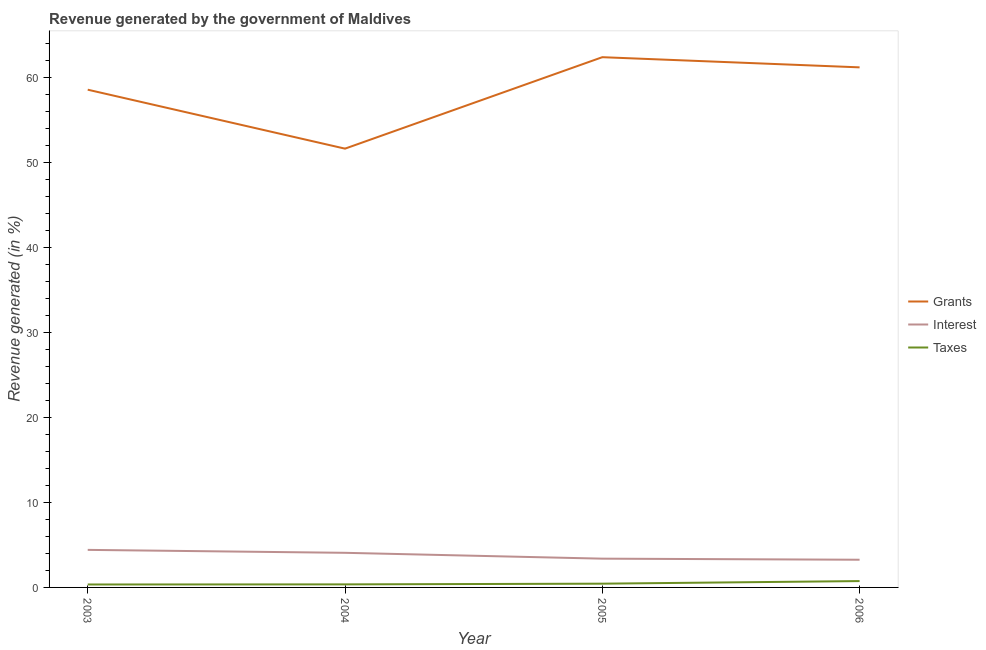Is the number of lines equal to the number of legend labels?
Provide a succinct answer. Yes. What is the percentage of revenue generated by interest in 2003?
Make the answer very short. 4.42. Across all years, what is the maximum percentage of revenue generated by interest?
Make the answer very short. 4.42. Across all years, what is the minimum percentage of revenue generated by grants?
Your response must be concise. 51.61. In which year was the percentage of revenue generated by grants maximum?
Give a very brief answer. 2005. In which year was the percentage of revenue generated by interest minimum?
Give a very brief answer. 2006. What is the total percentage of revenue generated by interest in the graph?
Provide a succinct answer. 15.13. What is the difference between the percentage of revenue generated by grants in 2003 and that in 2005?
Provide a short and direct response. -3.82. What is the difference between the percentage of revenue generated by grants in 2005 and the percentage of revenue generated by interest in 2003?
Offer a terse response. 57.95. What is the average percentage of revenue generated by grants per year?
Your response must be concise. 58.42. In the year 2003, what is the difference between the percentage of revenue generated by interest and percentage of revenue generated by taxes?
Give a very brief answer. 4.07. What is the ratio of the percentage of revenue generated by grants in 2004 to that in 2006?
Your answer should be compact. 0.84. What is the difference between the highest and the second highest percentage of revenue generated by interest?
Offer a very short reply. 0.35. What is the difference between the highest and the lowest percentage of revenue generated by grants?
Keep it short and to the point. 10.76. In how many years, is the percentage of revenue generated by interest greater than the average percentage of revenue generated by interest taken over all years?
Ensure brevity in your answer.  2. Is the sum of the percentage of revenue generated by interest in 2004 and 2005 greater than the maximum percentage of revenue generated by taxes across all years?
Offer a very short reply. Yes. Does the percentage of revenue generated by grants monotonically increase over the years?
Your answer should be very brief. No. Is the percentage of revenue generated by taxes strictly greater than the percentage of revenue generated by grants over the years?
Offer a very short reply. No. How many lines are there?
Give a very brief answer. 3. How many years are there in the graph?
Offer a very short reply. 4. What is the difference between two consecutive major ticks on the Y-axis?
Give a very brief answer. 10. Where does the legend appear in the graph?
Make the answer very short. Center right. How many legend labels are there?
Keep it short and to the point. 3. How are the legend labels stacked?
Your answer should be very brief. Vertical. What is the title of the graph?
Keep it short and to the point. Revenue generated by the government of Maldives. Does "Slovak Republic" appear as one of the legend labels in the graph?
Your response must be concise. No. What is the label or title of the X-axis?
Ensure brevity in your answer.  Year. What is the label or title of the Y-axis?
Your answer should be compact. Revenue generated (in %). What is the Revenue generated (in %) in Grants in 2003?
Your answer should be very brief. 58.54. What is the Revenue generated (in %) in Interest in 2003?
Keep it short and to the point. 4.42. What is the Revenue generated (in %) in Taxes in 2003?
Your answer should be compact. 0.35. What is the Revenue generated (in %) of Grants in 2004?
Provide a short and direct response. 51.61. What is the Revenue generated (in %) of Interest in 2004?
Provide a succinct answer. 4.07. What is the Revenue generated (in %) in Taxes in 2004?
Offer a very short reply. 0.36. What is the Revenue generated (in %) in Grants in 2005?
Your answer should be compact. 62.37. What is the Revenue generated (in %) in Interest in 2005?
Provide a short and direct response. 3.38. What is the Revenue generated (in %) of Taxes in 2005?
Your response must be concise. 0.44. What is the Revenue generated (in %) of Grants in 2006?
Ensure brevity in your answer.  61.17. What is the Revenue generated (in %) of Interest in 2006?
Your answer should be very brief. 3.26. What is the Revenue generated (in %) of Taxes in 2006?
Make the answer very short. 0.75. Across all years, what is the maximum Revenue generated (in %) in Grants?
Provide a succinct answer. 62.37. Across all years, what is the maximum Revenue generated (in %) of Interest?
Give a very brief answer. 4.42. Across all years, what is the maximum Revenue generated (in %) in Taxes?
Your answer should be very brief. 0.75. Across all years, what is the minimum Revenue generated (in %) in Grants?
Your answer should be compact. 51.61. Across all years, what is the minimum Revenue generated (in %) of Interest?
Ensure brevity in your answer.  3.26. Across all years, what is the minimum Revenue generated (in %) in Taxes?
Provide a succinct answer. 0.35. What is the total Revenue generated (in %) in Grants in the graph?
Keep it short and to the point. 233.69. What is the total Revenue generated (in %) of Interest in the graph?
Offer a terse response. 15.13. What is the total Revenue generated (in %) in Taxes in the graph?
Ensure brevity in your answer.  1.89. What is the difference between the Revenue generated (in %) in Grants in 2003 and that in 2004?
Offer a terse response. 6.93. What is the difference between the Revenue generated (in %) of Interest in 2003 and that in 2004?
Provide a short and direct response. 0.35. What is the difference between the Revenue generated (in %) in Taxes in 2003 and that in 2004?
Make the answer very short. -0.01. What is the difference between the Revenue generated (in %) of Grants in 2003 and that in 2005?
Your answer should be compact. -3.82. What is the difference between the Revenue generated (in %) in Interest in 2003 and that in 2005?
Your answer should be very brief. 1.03. What is the difference between the Revenue generated (in %) of Taxes in 2003 and that in 2005?
Provide a succinct answer. -0.09. What is the difference between the Revenue generated (in %) of Grants in 2003 and that in 2006?
Offer a terse response. -2.63. What is the difference between the Revenue generated (in %) of Interest in 2003 and that in 2006?
Offer a very short reply. 1.16. What is the difference between the Revenue generated (in %) in Taxes in 2003 and that in 2006?
Offer a very short reply. -0.4. What is the difference between the Revenue generated (in %) of Grants in 2004 and that in 2005?
Keep it short and to the point. -10.76. What is the difference between the Revenue generated (in %) in Interest in 2004 and that in 2005?
Give a very brief answer. 0.69. What is the difference between the Revenue generated (in %) of Taxes in 2004 and that in 2005?
Ensure brevity in your answer.  -0.08. What is the difference between the Revenue generated (in %) in Grants in 2004 and that in 2006?
Give a very brief answer. -9.56. What is the difference between the Revenue generated (in %) of Interest in 2004 and that in 2006?
Make the answer very short. 0.82. What is the difference between the Revenue generated (in %) of Taxes in 2004 and that in 2006?
Your answer should be very brief. -0.39. What is the difference between the Revenue generated (in %) in Grants in 2005 and that in 2006?
Your response must be concise. 1.2. What is the difference between the Revenue generated (in %) in Interest in 2005 and that in 2006?
Provide a succinct answer. 0.13. What is the difference between the Revenue generated (in %) of Taxes in 2005 and that in 2006?
Your response must be concise. -0.31. What is the difference between the Revenue generated (in %) of Grants in 2003 and the Revenue generated (in %) of Interest in 2004?
Give a very brief answer. 54.47. What is the difference between the Revenue generated (in %) in Grants in 2003 and the Revenue generated (in %) in Taxes in 2004?
Provide a short and direct response. 58.19. What is the difference between the Revenue generated (in %) in Interest in 2003 and the Revenue generated (in %) in Taxes in 2004?
Your response must be concise. 4.06. What is the difference between the Revenue generated (in %) in Grants in 2003 and the Revenue generated (in %) in Interest in 2005?
Make the answer very short. 55.16. What is the difference between the Revenue generated (in %) of Grants in 2003 and the Revenue generated (in %) of Taxes in 2005?
Offer a very short reply. 58.1. What is the difference between the Revenue generated (in %) of Interest in 2003 and the Revenue generated (in %) of Taxes in 2005?
Offer a very short reply. 3.98. What is the difference between the Revenue generated (in %) in Grants in 2003 and the Revenue generated (in %) in Interest in 2006?
Offer a terse response. 55.29. What is the difference between the Revenue generated (in %) in Grants in 2003 and the Revenue generated (in %) in Taxes in 2006?
Ensure brevity in your answer.  57.8. What is the difference between the Revenue generated (in %) of Interest in 2003 and the Revenue generated (in %) of Taxes in 2006?
Your answer should be compact. 3.67. What is the difference between the Revenue generated (in %) of Grants in 2004 and the Revenue generated (in %) of Interest in 2005?
Keep it short and to the point. 48.23. What is the difference between the Revenue generated (in %) in Grants in 2004 and the Revenue generated (in %) in Taxes in 2005?
Keep it short and to the point. 51.17. What is the difference between the Revenue generated (in %) of Interest in 2004 and the Revenue generated (in %) of Taxes in 2005?
Provide a short and direct response. 3.63. What is the difference between the Revenue generated (in %) of Grants in 2004 and the Revenue generated (in %) of Interest in 2006?
Your answer should be very brief. 48.35. What is the difference between the Revenue generated (in %) of Grants in 2004 and the Revenue generated (in %) of Taxes in 2006?
Keep it short and to the point. 50.86. What is the difference between the Revenue generated (in %) of Interest in 2004 and the Revenue generated (in %) of Taxes in 2006?
Provide a short and direct response. 3.32. What is the difference between the Revenue generated (in %) of Grants in 2005 and the Revenue generated (in %) of Interest in 2006?
Give a very brief answer. 59.11. What is the difference between the Revenue generated (in %) of Grants in 2005 and the Revenue generated (in %) of Taxes in 2006?
Keep it short and to the point. 61.62. What is the difference between the Revenue generated (in %) of Interest in 2005 and the Revenue generated (in %) of Taxes in 2006?
Your response must be concise. 2.64. What is the average Revenue generated (in %) in Grants per year?
Make the answer very short. 58.42. What is the average Revenue generated (in %) in Interest per year?
Provide a short and direct response. 3.78. What is the average Revenue generated (in %) in Taxes per year?
Keep it short and to the point. 0.47. In the year 2003, what is the difference between the Revenue generated (in %) in Grants and Revenue generated (in %) in Interest?
Make the answer very short. 54.13. In the year 2003, what is the difference between the Revenue generated (in %) in Grants and Revenue generated (in %) in Taxes?
Provide a short and direct response. 58.2. In the year 2003, what is the difference between the Revenue generated (in %) of Interest and Revenue generated (in %) of Taxes?
Give a very brief answer. 4.07. In the year 2004, what is the difference between the Revenue generated (in %) of Grants and Revenue generated (in %) of Interest?
Make the answer very short. 47.54. In the year 2004, what is the difference between the Revenue generated (in %) in Grants and Revenue generated (in %) in Taxes?
Your answer should be very brief. 51.25. In the year 2004, what is the difference between the Revenue generated (in %) of Interest and Revenue generated (in %) of Taxes?
Your answer should be very brief. 3.71. In the year 2005, what is the difference between the Revenue generated (in %) of Grants and Revenue generated (in %) of Interest?
Provide a short and direct response. 58.98. In the year 2005, what is the difference between the Revenue generated (in %) in Grants and Revenue generated (in %) in Taxes?
Offer a terse response. 61.93. In the year 2005, what is the difference between the Revenue generated (in %) of Interest and Revenue generated (in %) of Taxes?
Your answer should be compact. 2.94. In the year 2006, what is the difference between the Revenue generated (in %) of Grants and Revenue generated (in %) of Interest?
Offer a terse response. 57.91. In the year 2006, what is the difference between the Revenue generated (in %) in Grants and Revenue generated (in %) in Taxes?
Your response must be concise. 60.42. In the year 2006, what is the difference between the Revenue generated (in %) of Interest and Revenue generated (in %) of Taxes?
Provide a succinct answer. 2.51. What is the ratio of the Revenue generated (in %) in Grants in 2003 to that in 2004?
Your response must be concise. 1.13. What is the ratio of the Revenue generated (in %) in Interest in 2003 to that in 2004?
Ensure brevity in your answer.  1.08. What is the ratio of the Revenue generated (in %) of Taxes in 2003 to that in 2004?
Your response must be concise. 0.97. What is the ratio of the Revenue generated (in %) of Grants in 2003 to that in 2005?
Provide a succinct answer. 0.94. What is the ratio of the Revenue generated (in %) in Interest in 2003 to that in 2005?
Your answer should be very brief. 1.31. What is the ratio of the Revenue generated (in %) in Taxes in 2003 to that in 2005?
Give a very brief answer. 0.79. What is the ratio of the Revenue generated (in %) of Grants in 2003 to that in 2006?
Your response must be concise. 0.96. What is the ratio of the Revenue generated (in %) of Interest in 2003 to that in 2006?
Keep it short and to the point. 1.36. What is the ratio of the Revenue generated (in %) in Taxes in 2003 to that in 2006?
Make the answer very short. 0.46. What is the ratio of the Revenue generated (in %) in Grants in 2004 to that in 2005?
Make the answer very short. 0.83. What is the ratio of the Revenue generated (in %) in Interest in 2004 to that in 2005?
Offer a very short reply. 1.2. What is the ratio of the Revenue generated (in %) of Taxes in 2004 to that in 2005?
Give a very brief answer. 0.81. What is the ratio of the Revenue generated (in %) in Grants in 2004 to that in 2006?
Your answer should be very brief. 0.84. What is the ratio of the Revenue generated (in %) of Interest in 2004 to that in 2006?
Provide a succinct answer. 1.25. What is the ratio of the Revenue generated (in %) in Taxes in 2004 to that in 2006?
Your answer should be compact. 0.48. What is the ratio of the Revenue generated (in %) in Grants in 2005 to that in 2006?
Offer a terse response. 1.02. What is the ratio of the Revenue generated (in %) of Interest in 2005 to that in 2006?
Provide a short and direct response. 1.04. What is the ratio of the Revenue generated (in %) of Taxes in 2005 to that in 2006?
Your answer should be compact. 0.59. What is the difference between the highest and the second highest Revenue generated (in %) in Grants?
Your answer should be very brief. 1.2. What is the difference between the highest and the second highest Revenue generated (in %) of Interest?
Provide a short and direct response. 0.35. What is the difference between the highest and the second highest Revenue generated (in %) in Taxes?
Offer a very short reply. 0.31. What is the difference between the highest and the lowest Revenue generated (in %) of Grants?
Give a very brief answer. 10.76. What is the difference between the highest and the lowest Revenue generated (in %) of Interest?
Give a very brief answer. 1.16. What is the difference between the highest and the lowest Revenue generated (in %) of Taxes?
Give a very brief answer. 0.4. 